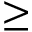Convert formula to latex. <formula><loc_0><loc_0><loc_500><loc_500>\geq</formula> 